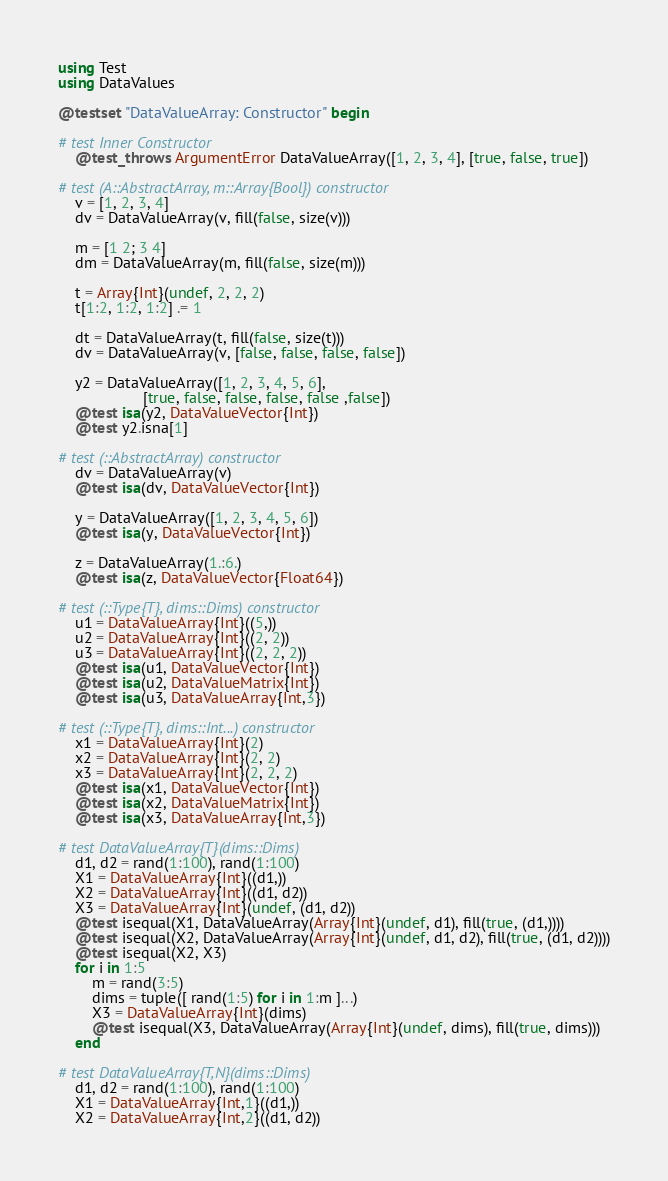<code> <loc_0><loc_0><loc_500><loc_500><_Julia_>using Test
using DataValues

@testset "DataValueArray: Constructor" begin

# test Inner Constructor
    @test_throws ArgumentError DataValueArray([1, 2, 3, 4], [true, false, true])

# test (A::AbstractArray, m::Array{Bool}) constructor
    v = [1, 2, 3, 4]
    dv = DataValueArray(v, fill(false, size(v)))

    m = [1 2; 3 4]
    dm = DataValueArray(m, fill(false, size(m)))

    t = Array{Int}(undef, 2, 2, 2)
    t[1:2, 1:2, 1:2] .= 1

    dt = DataValueArray(t, fill(false, size(t)))
    dv = DataValueArray(v, [false, false, false, false])

    y2 = DataValueArray([1, 2, 3, 4, 5, 6],
                    [true, false, false, false, false ,false])
    @test isa(y2, DataValueVector{Int})
    @test y2.isna[1]

# test (::AbstractArray) constructor
    dv = DataValueArray(v)
    @test isa(dv, DataValueVector{Int})

    y = DataValueArray([1, 2, 3, 4, 5, 6])
    @test isa(y, DataValueVector{Int})

    z = DataValueArray(1.:6.)
    @test isa(z, DataValueVector{Float64})

# test (::Type{T}, dims::Dims) constructor
    u1 = DataValueArray{Int}((5,))
    u2 = DataValueArray{Int}((2, 2))
    u3 = DataValueArray{Int}((2, 2, 2))
    @test isa(u1, DataValueVector{Int})
    @test isa(u2, DataValueMatrix{Int})
    @test isa(u3, DataValueArray{Int,3})

# test (::Type{T}, dims::Int...) constructor
    x1 = DataValueArray{Int}(2)
    x2 = DataValueArray{Int}(2, 2)
    x3 = DataValueArray{Int}(2, 2, 2)
    @test isa(x1, DataValueVector{Int})
    @test isa(x2, DataValueMatrix{Int})
    @test isa(x3, DataValueArray{Int,3})

# test DataValueArray{T}(dims::Dims)
    d1, d2 = rand(1:100), rand(1:100)
    X1 = DataValueArray{Int}((d1,))
    X2 = DataValueArray{Int}((d1, d2))
    X3 = DataValueArray{Int}(undef, (d1, d2))
    @test isequal(X1, DataValueArray(Array{Int}(undef, d1), fill(true, (d1,))))
    @test isequal(X2, DataValueArray(Array{Int}(undef, d1, d2), fill(true, (d1, d2))))
    @test isequal(X2, X3)
    for i in 1:5
        m = rand(3:5)
        dims = tuple([ rand(1:5) for i in 1:m ]...)
        X3 = DataValueArray{Int}(dims)
        @test isequal(X3, DataValueArray(Array{Int}(undef, dims), fill(true, dims)))
    end

# test DataValueArray{T,N}(dims::Dims)
    d1, d2 = rand(1:100), rand(1:100)
    X1 = DataValueArray{Int,1}((d1,))
    X2 = DataValueArray{Int,2}((d1, d2))</code> 